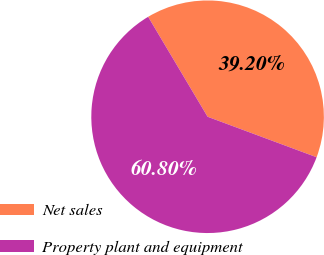Convert chart. <chart><loc_0><loc_0><loc_500><loc_500><pie_chart><fcel>Net sales<fcel>Property plant and equipment<nl><fcel>39.2%<fcel>60.8%<nl></chart> 